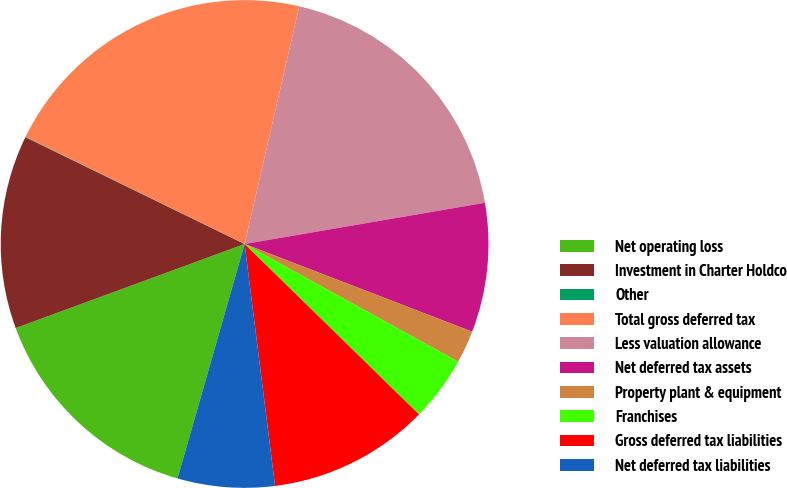Convert chart to OTSL. <chart><loc_0><loc_0><loc_500><loc_500><pie_chart><fcel>Net operating loss<fcel>Investment in Charter Holdco<fcel>Other<fcel>Total gross deferred tax<fcel>Less valuation allowance<fcel>Net deferred tax assets<fcel>Property plant & equipment<fcel>Franchises<fcel>Gross deferred tax liabilities<fcel>Net deferred tax liabilities<nl><fcel>14.96%<fcel>12.82%<fcel>0.03%<fcel>21.35%<fcel>18.7%<fcel>8.56%<fcel>2.16%<fcel>4.3%<fcel>10.69%<fcel>6.43%<nl></chart> 